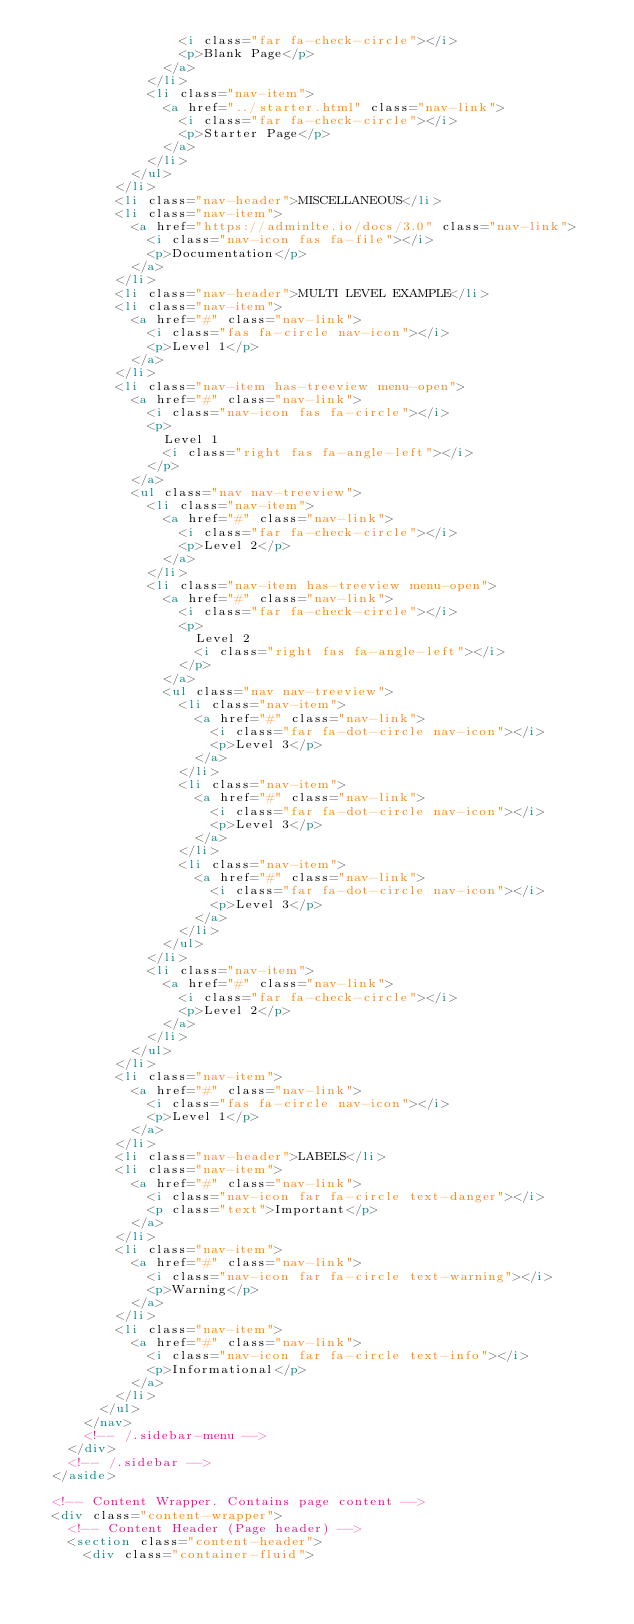<code> <loc_0><loc_0><loc_500><loc_500><_HTML_>                  <i class="far fa-check-circle"></i>
                  <p>Blank Page</p>
                </a>
              </li>
              <li class="nav-item">
                <a href="../starter.html" class="nav-link">
                  <i class="far fa-check-circle"></i>
                  <p>Starter Page</p>
                </a>
              </li>
            </ul>
          </li>
          <li class="nav-header">MISCELLANEOUS</li>
          <li class="nav-item">
            <a href="https://adminlte.io/docs/3.0" class="nav-link">
              <i class="nav-icon fas fa-file"></i>
              <p>Documentation</p>
            </a>
          </li>
          <li class="nav-header">MULTI LEVEL EXAMPLE</li>
          <li class="nav-item">
            <a href="#" class="nav-link">
              <i class="fas fa-circle nav-icon"></i>
              <p>Level 1</p>
            </a>
          </li>
          <li class="nav-item has-treeview menu-open">
            <a href="#" class="nav-link">
              <i class="nav-icon fas fa-circle"></i>
              <p>
                Level 1
                <i class="right fas fa-angle-left"></i>
              </p>
            </a>
            <ul class="nav nav-treeview">
              <li class="nav-item">
                <a href="#" class="nav-link">
                  <i class="far fa-check-circle"></i>
                  <p>Level 2</p>
                </a>
              </li>
              <li class="nav-item has-treeview menu-open">
                <a href="#" class="nav-link">
                  <i class="far fa-check-circle"></i>
                  <p>
                    Level 2
                    <i class="right fas fa-angle-left"></i>
                  </p>
                </a>
                <ul class="nav nav-treeview">
                  <li class="nav-item">
                    <a href="#" class="nav-link">
                      <i class="far fa-dot-circle nav-icon"></i>
                      <p>Level 3</p>
                    </a>
                  </li>
                  <li class="nav-item">
                    <a href="#" class="nav-link">
                      <i class="far fa-dot-circle nav-icon"></i>
                      <p>Level 3</p>
                    </a>
                  </li>
                  <li class="nav-item">
                    <a href="#" class="nav-link">
                      <i class="far fa-dot-circle nav-icon"></i>
                      <p>Level 3</p>
                    </a>
                  </li>
                </ul>
              </li>
              <li class="nav-item">
                <a href="#" class="nav-link">
                  <i class="far fa-check-circle"></i>
                  <p>Level 2</p>
                </a>
              </li>
            </ul>
          </li>
          <li class="nav-item">
            <a href="#" class="nav-link">
              <i class="fas fa-circle nav-icon"></i>
              <p>Level 1</p>
            </a>
          </li>
          <li class="nav-header">LABELS</li>
          <li class="nav-item">
            <a href="#" class="nav-link">
              <i class="nav-icon far fa-circle text-danger"></i>
              <p class="text">Important</p>
            </a>
          </li>
          <li class="nav-item">
            <a href="#" class="nav-link">
              <i class="nav-icon far fa-circle text-warning"></i>
              <p>Warning</p>
            </a>
          </li>
          <li class="nav-item">
            <a href="#" class="nav-link">
              <i class="nav-icon far fa-circle text-info"></i>
              <p>Informational</p>
            </a>
          </li>
        </ul>
      </nav>
      <!-- /.sidebar-menu -->
    </div>
    <!-- /.sidebar -->
  </aside>

  <!-- Content Wrapper. Contains page content -->
  <div class="content-wrapper">
    <!-- Content Header (Page header) -->
    <section class="content-header">
      <div class="container-fluid"></code> 